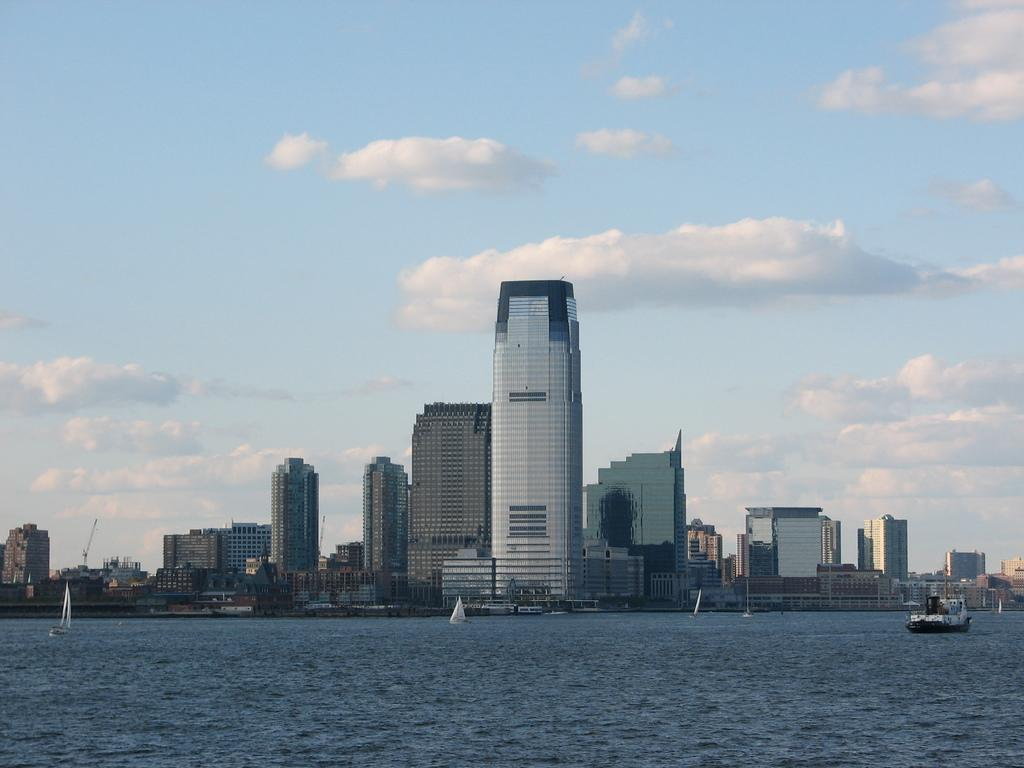What is the main subject of the image? The main subject of the image is water. What is present on the water? There are boats on the water. What can be seen in the background of the image? There are buildings in the background of the image. How would you describe the sky in the image? The sky is cloudy in the image. What type of tin is being used to make the boats in the image? There is no mention of tin being used to make the boats in the image. The boats are simply present on the water. Can you tell me how many credits are required to rent one of the boats in the image? There is no information about renting boats or credits in the image. The image only shows boats on the water. 